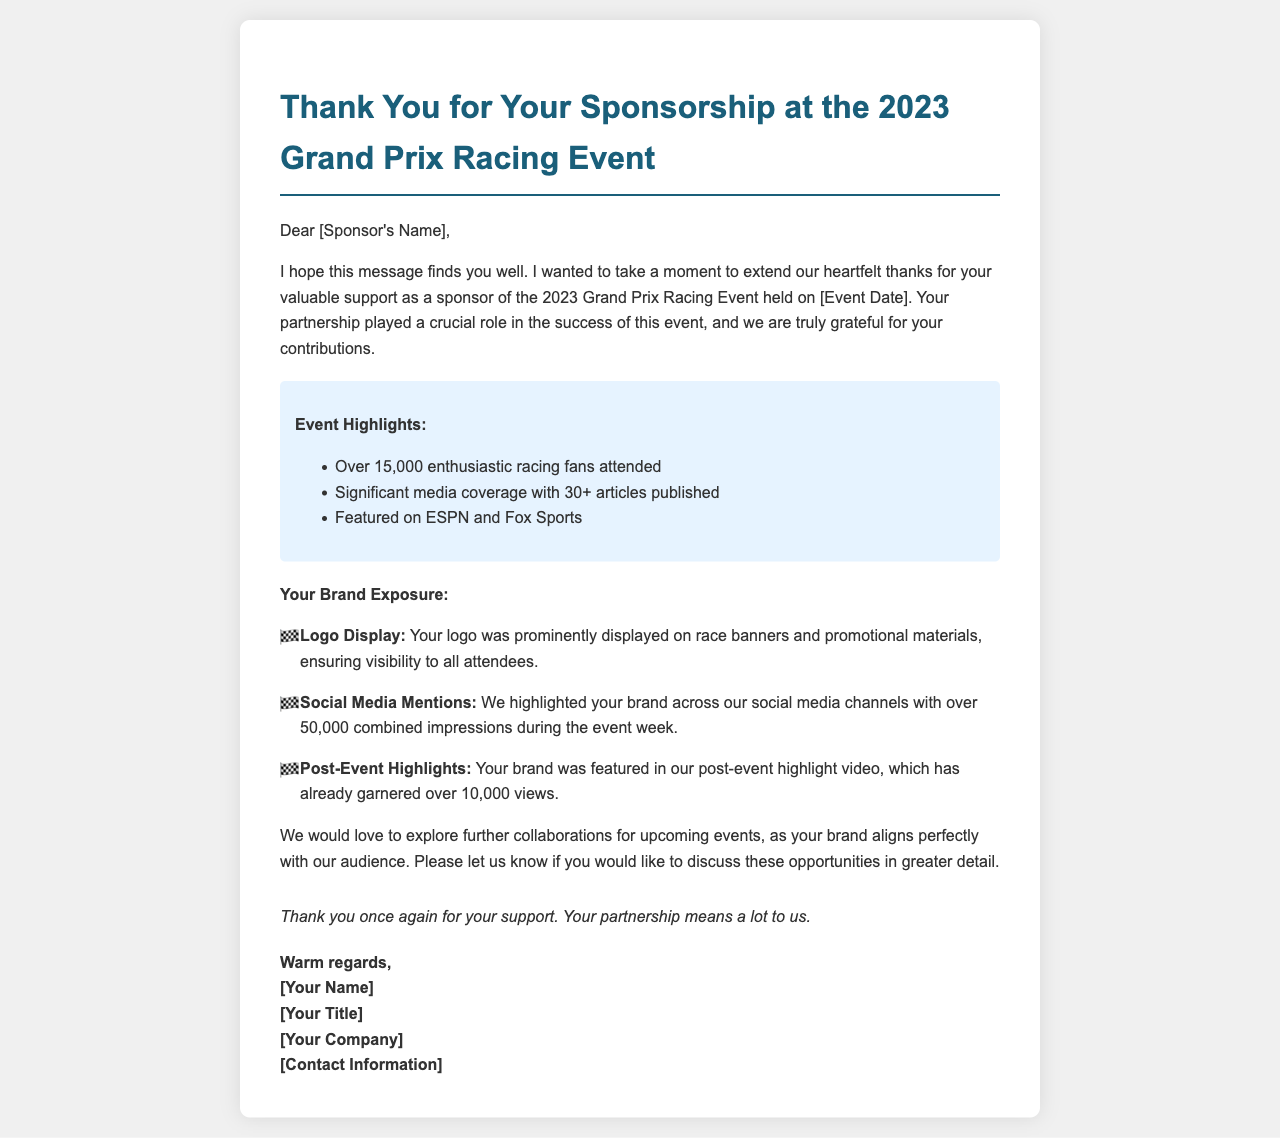what is the name of the event discussed in the letter? The name of the event is explicitly mentioned in the title of the letter as the "2023 Grand Prix Racing Event."
Answer: 2023 Grand Prix Racing Event who is the recipient of the letter? The recipient's name is indicated as "[Sponsor's Name]," which signifies that it's a placeholder for the actual sponsor's name.
Answer: [Sponsor's Name] how many people attended the event? The letter states that over 15,000 enthusiastic racing fans attended, which gives a specific audience count.
Answer: over 15,000 how many articles covered the event? The document specifies that there was significant media coverage with 30+ articles published, providing a quantifiable measure of exposure.
Answer: 30+ what was the total number of impressions made on social media? The letter mentions that there were over 50,000 combined impressions across social media channels during the event week, representing the level of brand visibility.
Answer: over 50,000 what type of document is this? The content and structure, which includes a greeting, body, and closing, indicate that this is a follow-up letter directed to sponsors after an event.
Answer: letter what additional opportunities does the letter mention? The letter expresses interest in exploring further collaborations for upcoming events, which indicates future partnership possibilities.
Answer: further collaborations what is one highlighted feature of the brand exposure? One main feature mentioned is that the brand's logo was prominently displayed on race banners and promotional materials.
Answer: Logo Display how many views did the post-event highlight video receive? The document notes that the post-event highlight video has already garnered over 10,000 views, which serves as a measure of success for brand sponsorship.
Answer: over 10,000 